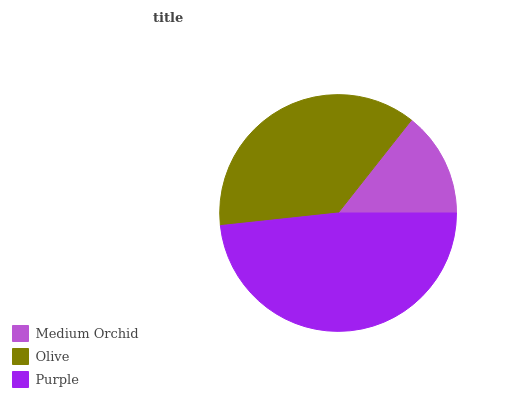Is Medium Orchid the minimum?
Answer yes or no. Yes. Is Purple the maximum?
Answer yes or no. Yes. Is Olive the minimum?
Answer yes or no. No. Is Olive the maximum?
Answer yes or no. No. Is Olive greater than Medium Orchid?
Answer yes or no. Yes. Is Medium Orchid less than Olive?
Answer yes or no. Yes. Is Medium Orchid greater than Olive?
Answer yes or no. No. Is Olive less than Medium Orchid?
Answer yes or no. No. Is Olive the high median?
Answer yes or no. Yes. Is Olive the low median?
Answer yes or no. Yes. Is Medium Orchid the high median?
Answer yes or no. No. Is Medium Orchid the low median?
Answer yes or no. No. 